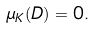<formula> <loc_0><loc_0><loc_500><loc_500>\mu _ { K } ( D ) = 0 .</formula> 